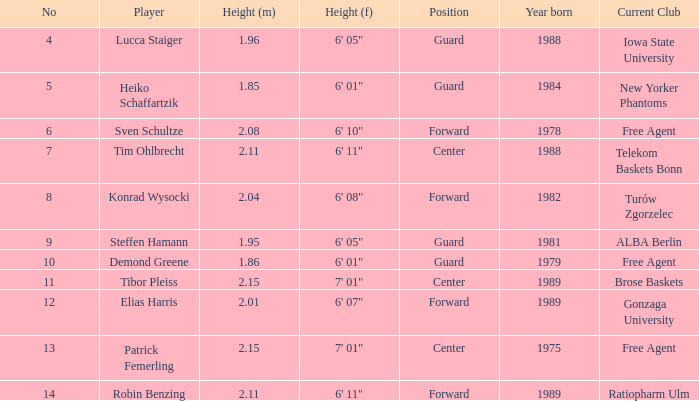Identify the height of the athlete born in 1989 and measuring 6' 11". 